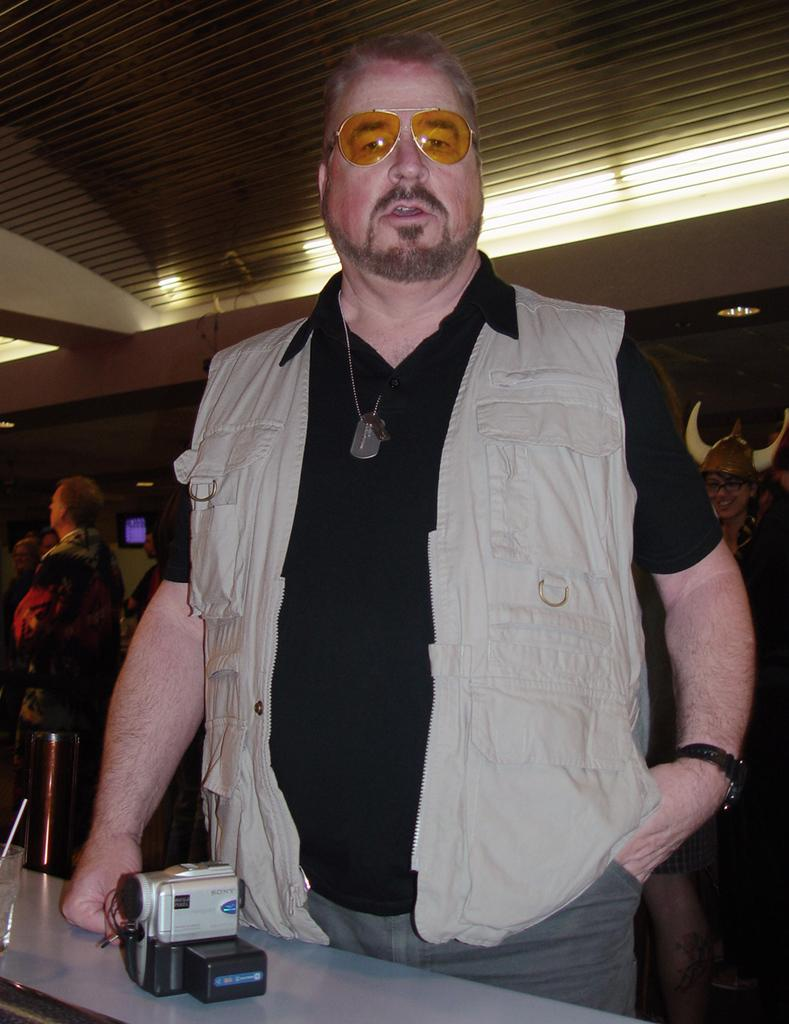Who is present in the image? There is a man in the image. What is the man wearing? The man is wearing spectacles. What object is on the table in front of the man? There is a camera on a table in front of the man. What can be seen in the background of the image? There are people and lights visible in the background of the image. What type of faucet is visible in the image? There is no faucet present in the image. What drink is the man holding in the image? The image does not show the man holding any drink. 